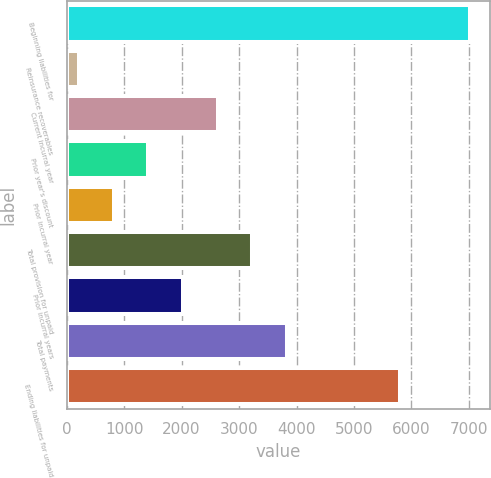<chart> <loc_0><loc_0><loc_500><loc_500><bar_chart><fcel>Beginning liabilities for<fcel>Reinsurance recoverables<fcel>Current incurral year<fcel>Prior year's discount<fcel>Prior incurral year<fcel>Total provision for unpaid<fcel>Prior incurral years<fcel>Total payments<fcel>Ending liabilities for unpaid<nl><fcel>7013.6<fcel>210<fcel>2629.2<fcel>1419.6<fcel>814.8<fcel>3234<fcel>2024.4<fcel>3838.8<fcel>5804<nl></chart> 